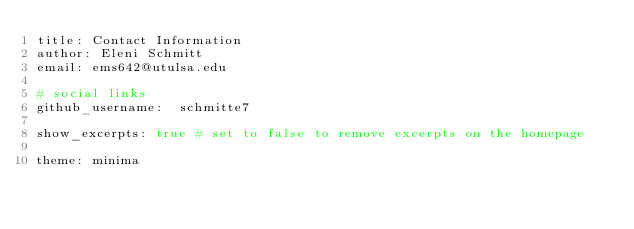<code> <loc_0><loc_0><loc_500><loc_500><_YAML_>title: Contact Information
author: Eleni Schmitt
email: ems642@utulsa.edu

# social links
github_username:  schmitte7

show_excerpts: true # set to false to remove excerpts on the homepage

theme: minima
</code> 